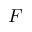Convert formula to latex. <formula><loc_0><loc_0><loc_500><loc_500>F</formula> 